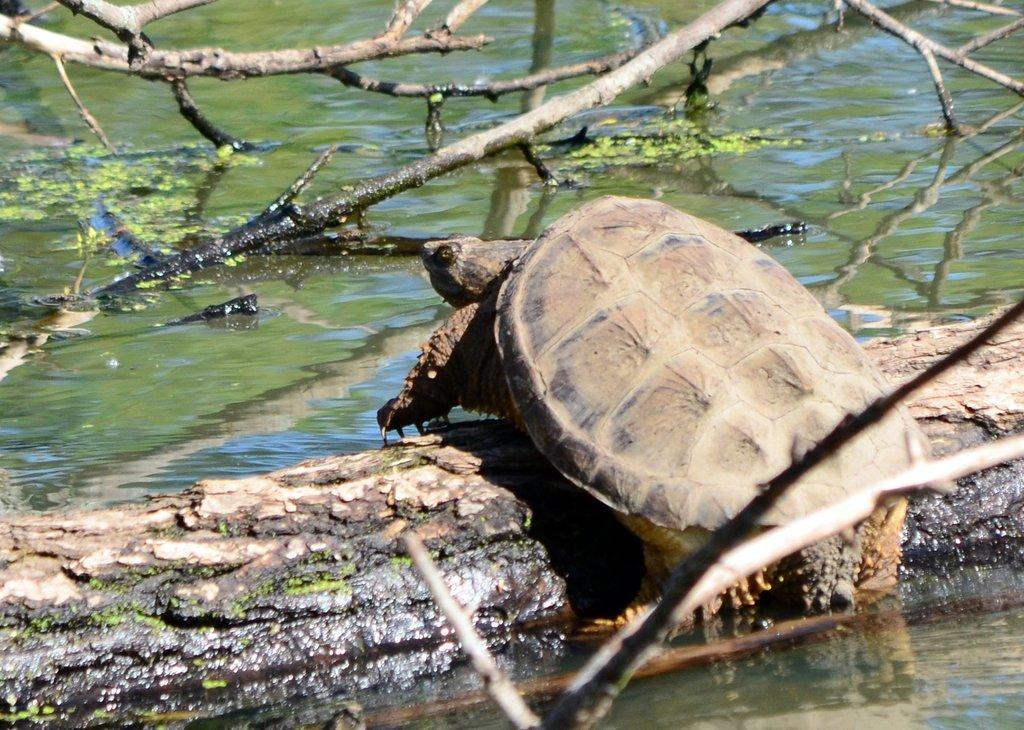What animal is present in the image? There is a tortoise in the image. Where is the tortoise located? The tortoise is on a wood log. What is the wood log placed on? The wood log is placed in water. What can be seen in the background of the image? There are branches of trees in the background of the image. What type of glue is being used to attach the rifle to the can in the image? There is no glue, rifle, or can present in the image. 